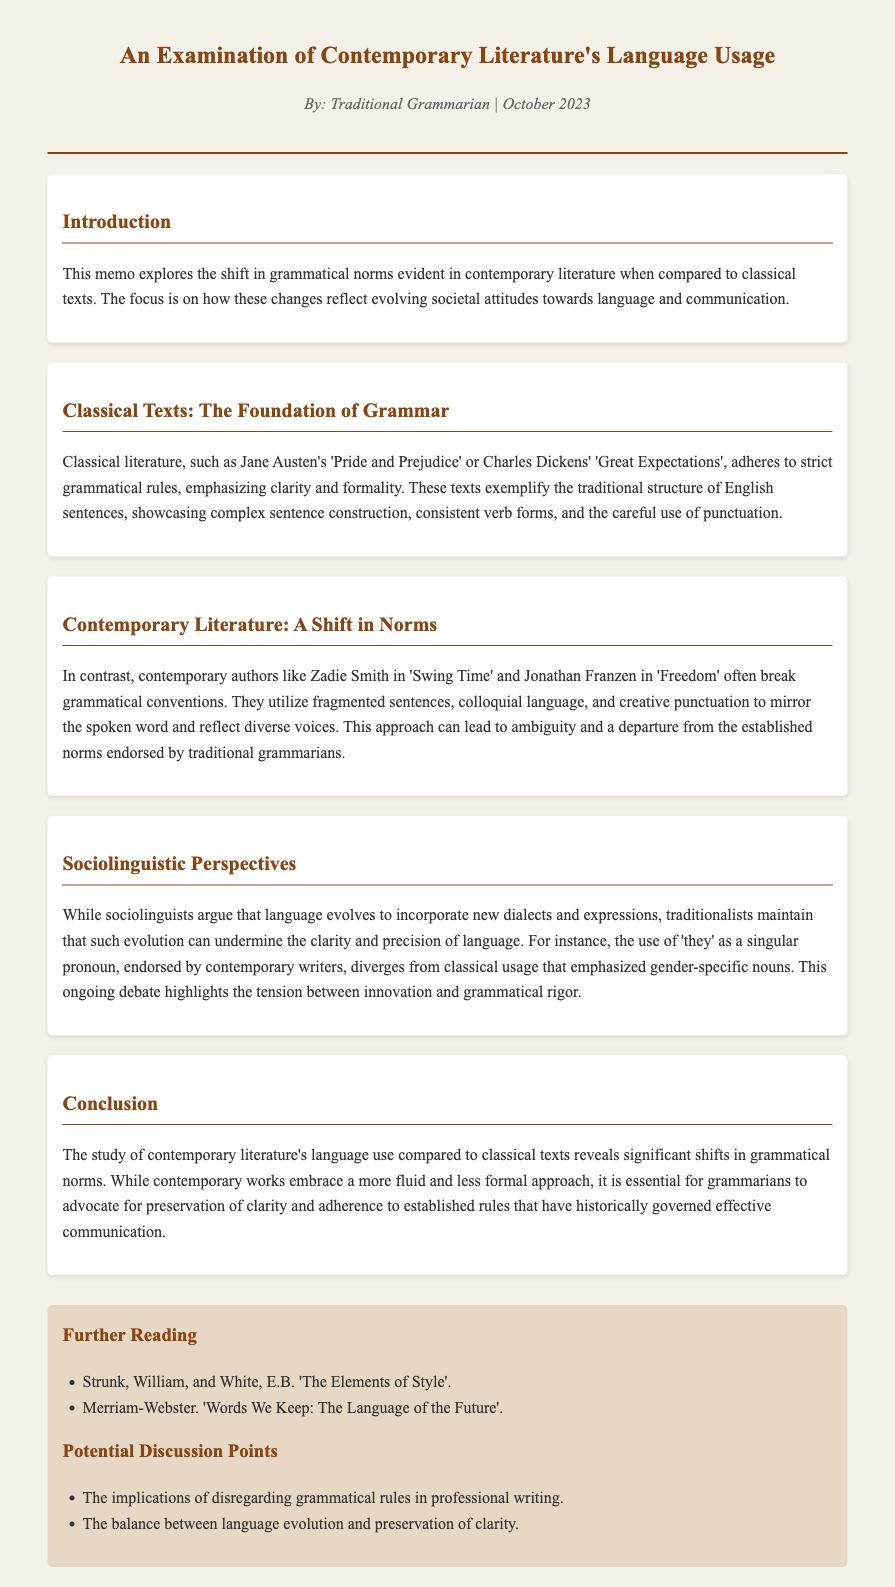What is the title of the memo? The title is stated at the beginning of the document and highlights the subject of the examination.
Answer: An Examination of Contemporary Literature's Language Usage Who is the author of the memo? The author is mentioned in the author date section and identifies their perspective on the subject matter.
Answer: Traditional Grammarian What are two contemporary authors mentioned in the document? These authors are specifically referenced in the section about contemporary literature and their works illustrate modern grammatical norms.
Answer: Zadie Smith, Jonathan Franzen What classic text is cited as an example of strict grammatical rules? This classic author is brought up in the context of how grammar was adhered to in historical literature.
Answer: Pride and Prejudice What is one potential discussion point suggested in the memo? Discussion points are provided in the suggestions section, relating to grammar and language use.
Answer: The balance between language evolution and preservation of clarity What grammatical convention is noted as broken in contemporary literature? This detail concerns the way contemporary authors diverge from traditional grammar structures to reflect modern speech patterns.
Answer: Fragmented sentences What is emphasized as a feature of classical literature? This aspect is highlighted in contrast to contemporary works that have different stylistic approaches.
Answer: Clarity and formality What societal aspect does the document suggest influences language changes? This notion is presented in the context of how modern texts differ from classical ones.
Answer: Evolving societal attitudes 